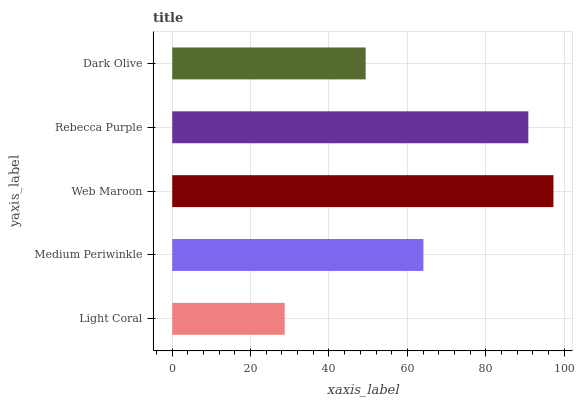Is Light Coral the minimum?
Answer yes or no. Yes. Is Web Maroon the maximum?
Answer yes or no. Yes. Is Medium Periwinkle the minimum?
Answer yes or no. No. Is Medium Periwinkle the maximum?
Answer yes or no. No. Is Medium Periwinkle greater than Light Coral?
Answer yes or no. Yes. Is Light Coral less than Medium Periwinkle?
Answer yes or no. Yes. Is Light Coral greater than Medium Periwinkle?
Answer yes or no. No. Is Medium Periwinkle less than Light Coral?
Answer yes or no. No. Is Medium Periwinkle the high median?
Answer yes or no. Yes. Is Medium Periwinkle the low median?
Answer yes or no. Yes. Is Rebecca Purple the high median?
Answer yes or no. No. Is Rebecca Purple the low median?
Answer yes or no. No. 